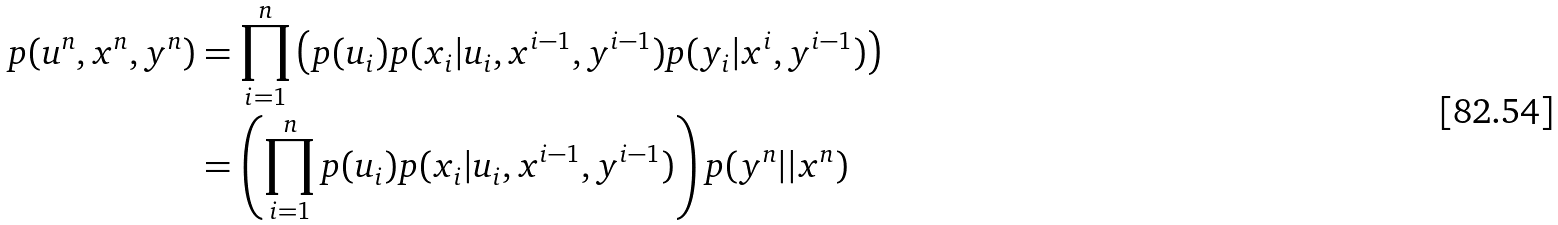Convert formula to latex. <formula><loc_0><loc_0><loc_500><loc_500>p ( u ^ { n } , x ^ { n } , y ^ { n } ) & = \prod _ { i = 1 } ^ { n } \left ( p ( u _ { i } ) p ( x _ { i } | u _ { i } , x ^ { i - 1 } , y ^ { i - 1 } ) p ( y _ { i } | x ^ { i } , y ^ { i - 1 } ) \right ) \\ & = \left ( \prod _ { i = 1 } ^ { n } p ( u _ { i } ) p ( x _ { i } | u _ { i } , x ^ { i - 1 } , y ^ { i - 1 } ) \right ) p ( y ^ { n } | | x ^ { n } )</formula> 